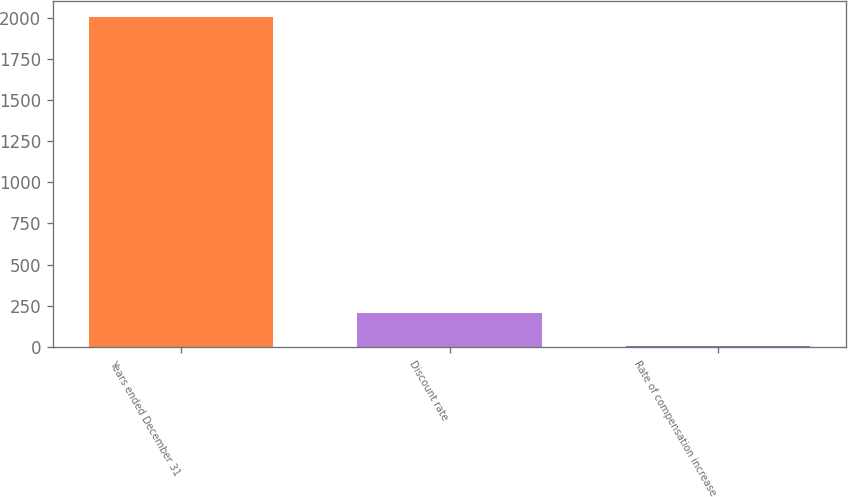Convert chart. <chart><loc_0><loc_0><loc_500><loc_500><bar_chart><fcel>Years ended December 31<fcel>Discount rate<fcel>Rate of compensation increase<nl><fcel>2001<fcel>203.7<fcel>4<nl></chart> 